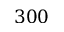<formula> <loc_0><loc_0><loc_500><loc_500>3 0 0</formula> 